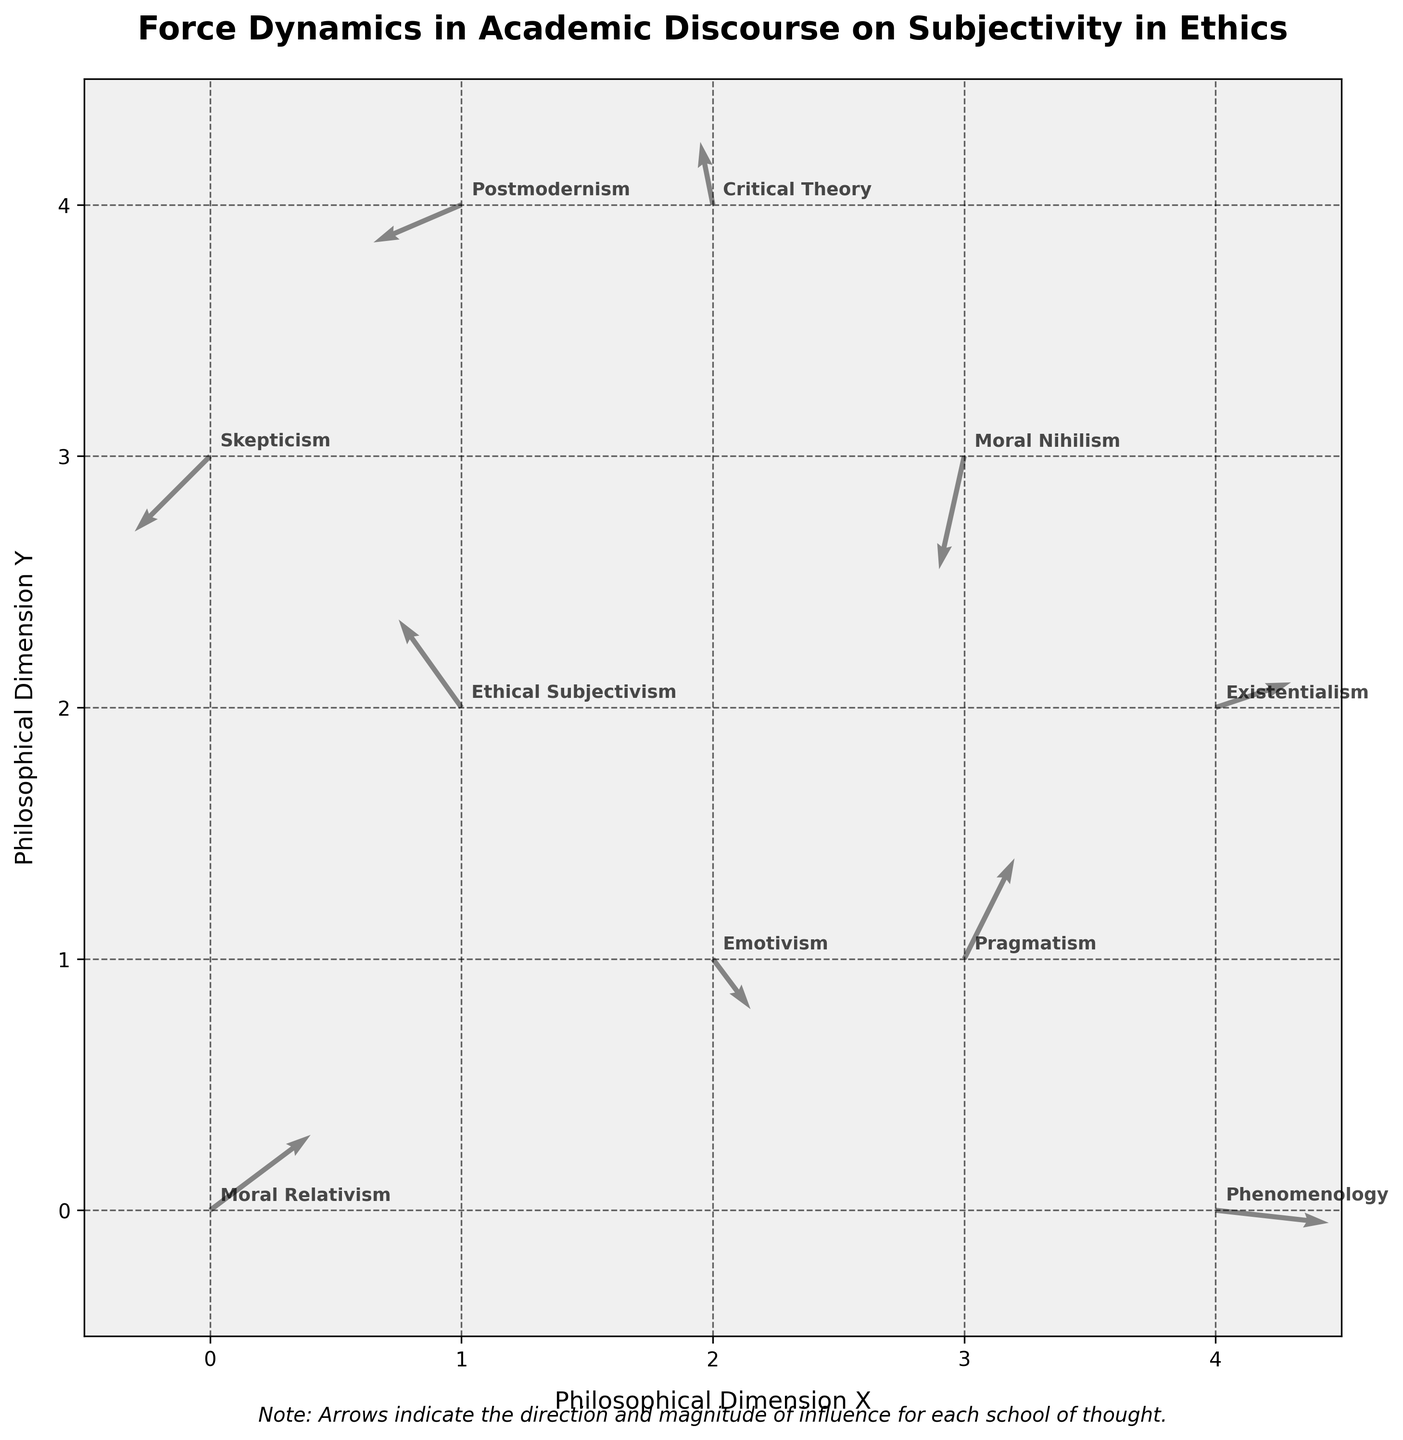What is the title of the figure? The title is usually located at the top center of the figure, in bold and larger font, which describes the main content of the plot. In this case, it reads "Force Dynamics in Academic Discourse on Subjectivity in Ethics".
Answer: Force Dynamics in Academic Discourse on Subjectivity in Ethics How many schools of thought are represented in the plot? To find the number of schools of thought, you can count the number of unique labels annotated on the plot. Counting each unique label, we get 10 schools of thought.
Answer: 10 Which school of thought shows the strongest directional influence and in which direction? The strongest directional influence is represented by the largest arrow. By comparing the length and direction of all arrows, we find that "Phenomenology" at (4, 0) has the largest vector (u=0.9, v=-0.1) pointing approximately towards the right.
Answer: Phenomenology, towards the right Which school of thought is represented at the coordinates (0, 0)? By examining the labels annotated at specific coordinates, we can verify the school of thought located at position (0, 0). The label at (0, 0) reads "Moral Relativism".
Answer: Moral Relativism What is the general direction of influence for the school of thought, "Moral Nihilism"? To determine the direction of influence, look at the vector’s orientation starting from the point (3, 3). The vector for "Moral Nihilism" (u=-0.2, v=-0.9) points downward and slightly left.
Answer: Downward and slightly left How do the influences of "Pragmatism" and "Critical Theory" compare in direction? Compare the vectors of both schools: Pragmatism at (3,1) has a vector (u=0.4, v=0.8) going upwards and right. Critical Theory at (2, 4) has a vector (u=-0.1, v=0.5) going upwards but slightly left. Both point upwards, but one is more rightward while the other is more leftward.
Answer: Both upward, Pragmatism more rightward, Critical Theory more leftward What schools of thought have a negative influence in both x and y dimensions? Identify the vectors with negative components for both x and y. These include the positions (3, 3) for "Moral Nihilism" and (0, 3) for "Skepticism", where the vectors are both pointing leftward and downward.
Answer: Moral Nihilism, Skepticism What is the average x-component of the vectors for the schools of thought located at (0, 0), (1, 2), and (2, 1)? First, identify the x-components of the vectors at these points: Moral Relativism (0.8), Ethical Subjectivism (-0.5), and Emotivism (0.3). Calculate the average: (0.8 - 0.5 + 0.3) / 3 = 0.2
Answer: 0.2 Which school of thought at coordinates (4, 2) has the least change in influence magnitude in the y-dimension? Analyze the y-components of vectors at this coordinate (4, 2) to determine the smallest value. Existentialism at (4, 2) has a vector component v=0.2, which indicates minimal change in the y-direction.
Answer: Existentialism In which quadrant do most schools of thought with a positive x influence reside? Observe the vectors with positive x-components (rightward) and note their quadrants. Positive x influences are found more frequently in Quadrants I (top-right) and IV (bottom-right). Here, most reside in Quadrant I.
Answer: Quadrant I 